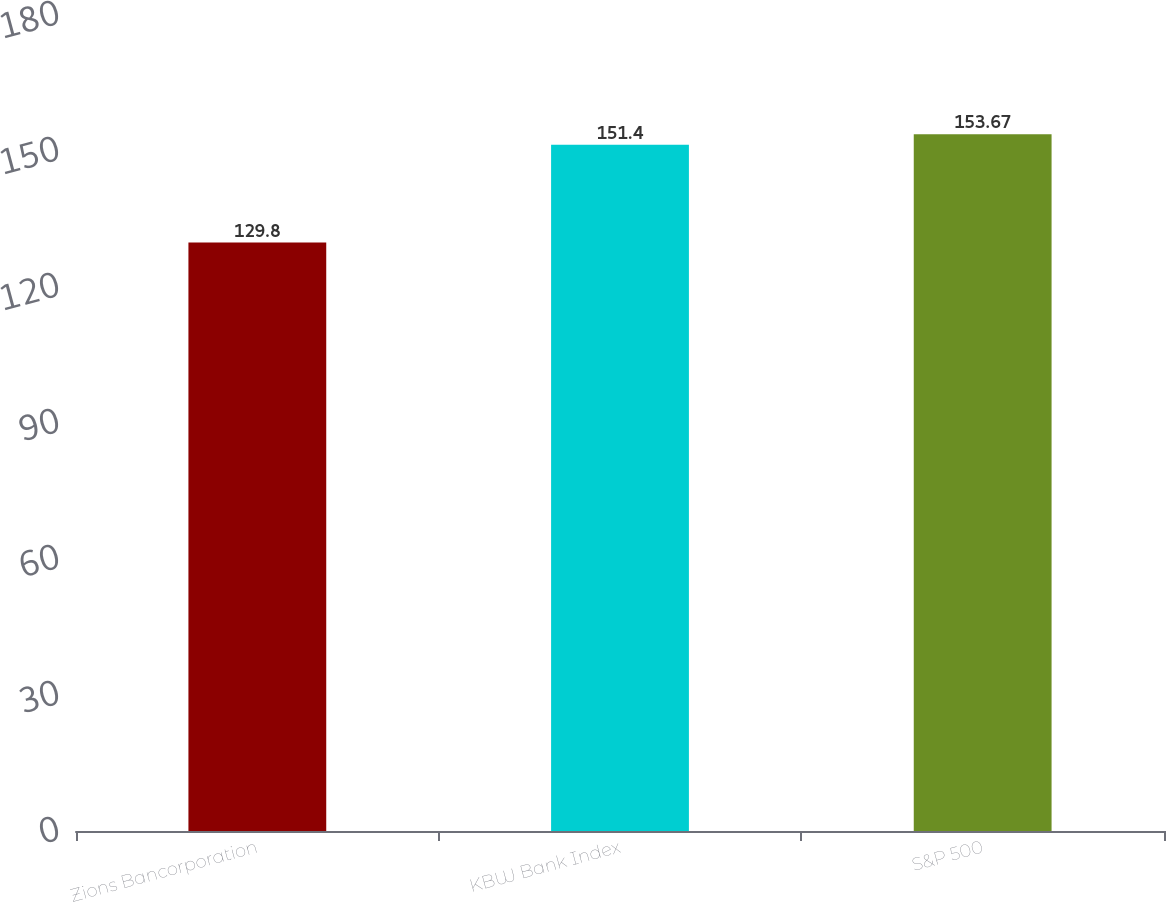<chart> <loc_0><loc_0><loc_500><loc_500><bar_chart><fcel>Zions Bancorporation<fcel>KBW Bank Index<fcel>S&P 500<nl><fcel>129.8<fcel>151.4<fcel>153.67<nl></chart> 